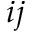<formula> <loc_0><loc_0><loc_500><loc_500>i j</formula> 